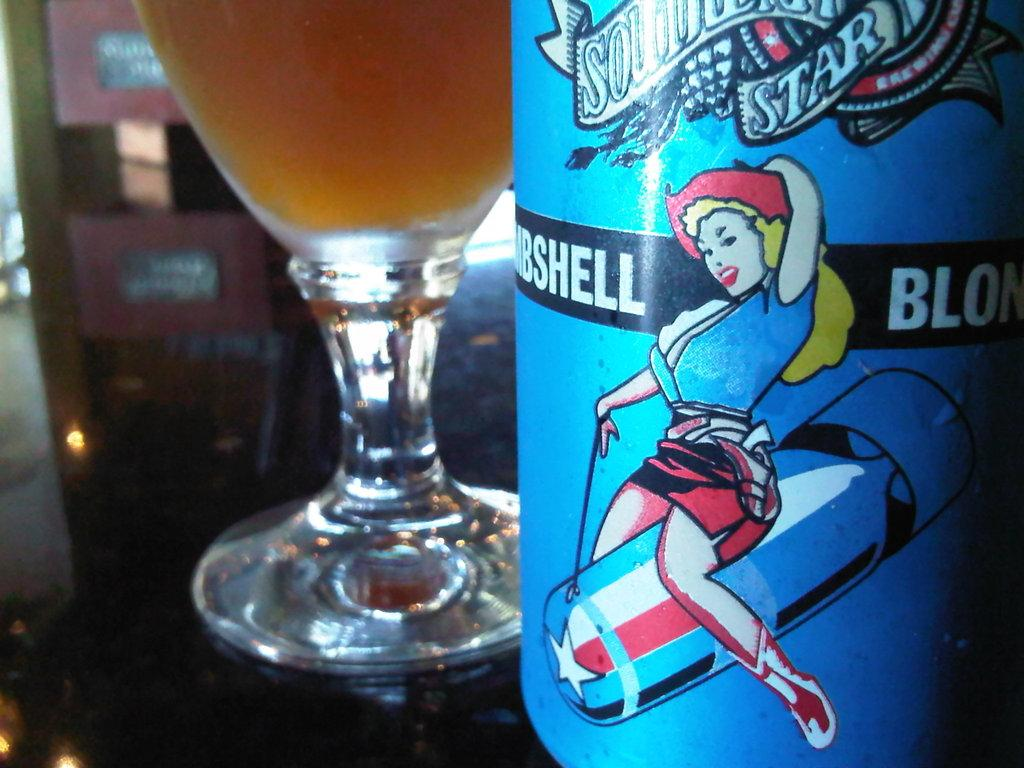Provide a one-sentence caption for the provided image. a partly seen bottle of Bombshell Blonde liquor and a glass filled with it. 